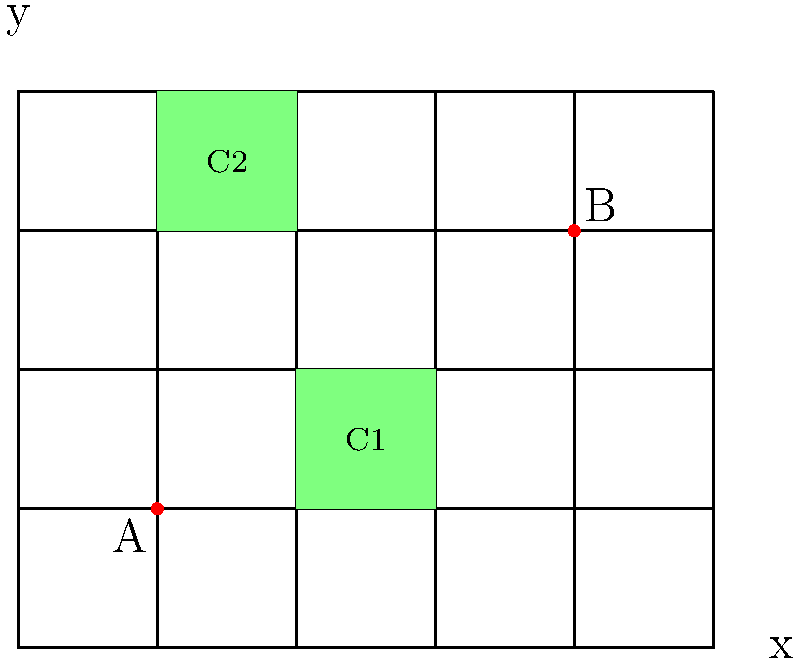In a restaurant, two air purifiers (A and B) are placed on a grid system as shown. The grid represents the floor plan, where each unit is 2 meters. Two customer areas (C1 and C2) are highlighted in green. Calculate the Manhattan distance between the air purifier that is closest to C1 and the center of C2. How can this information be used to optimize air purifier placement? Let's approach this step-by-step:

1) First, we need to identify the coordinates of the air purifiers and the centers of the customer areas:
   - Air purifier A: (1, 1)
   - Air purifier B: (4, 3)
   - Center of C1: (2.5, 1.5)
   - Center of C2: (1.5, 3.5)

2) To determine which air purifier is closest to C1, we calculate the Manhattan distances:
   - Distance from A to C1: |1 - 2.5| + |1 - 1.5| = 1.5 + 0.5 = 2
   - Distance from B to C1: |4 - 2.5| + |3 - 1.5| = 1.5 + 1.5 = 3

3) Air purifier A is closer to C1.

4) Now, we calculate the Manhattan distance between A and the center of C2:
   |1 - 1.5| + |1 - 3.5| = 0.5 + 2.5 = 3

5) Therefore, the Manhattan distance is 3 grid units, which equals 6 meters (since each unit is 2 meters).

To optimize air purifier placement:
- This distance indicates that air purifier A might not effectively serve both customer areas.
- Consider moving air purifier A to (2, 2) to better cover both C1 and C2.
- Alternatively, add a third air purifier near C2 for more comprehensive coverage.
- Regular assessment of air quality in different areas can help fine-tune purifier placement.
Answer: 6 meters; Move A to (2,2) or add a third purifier near C2 